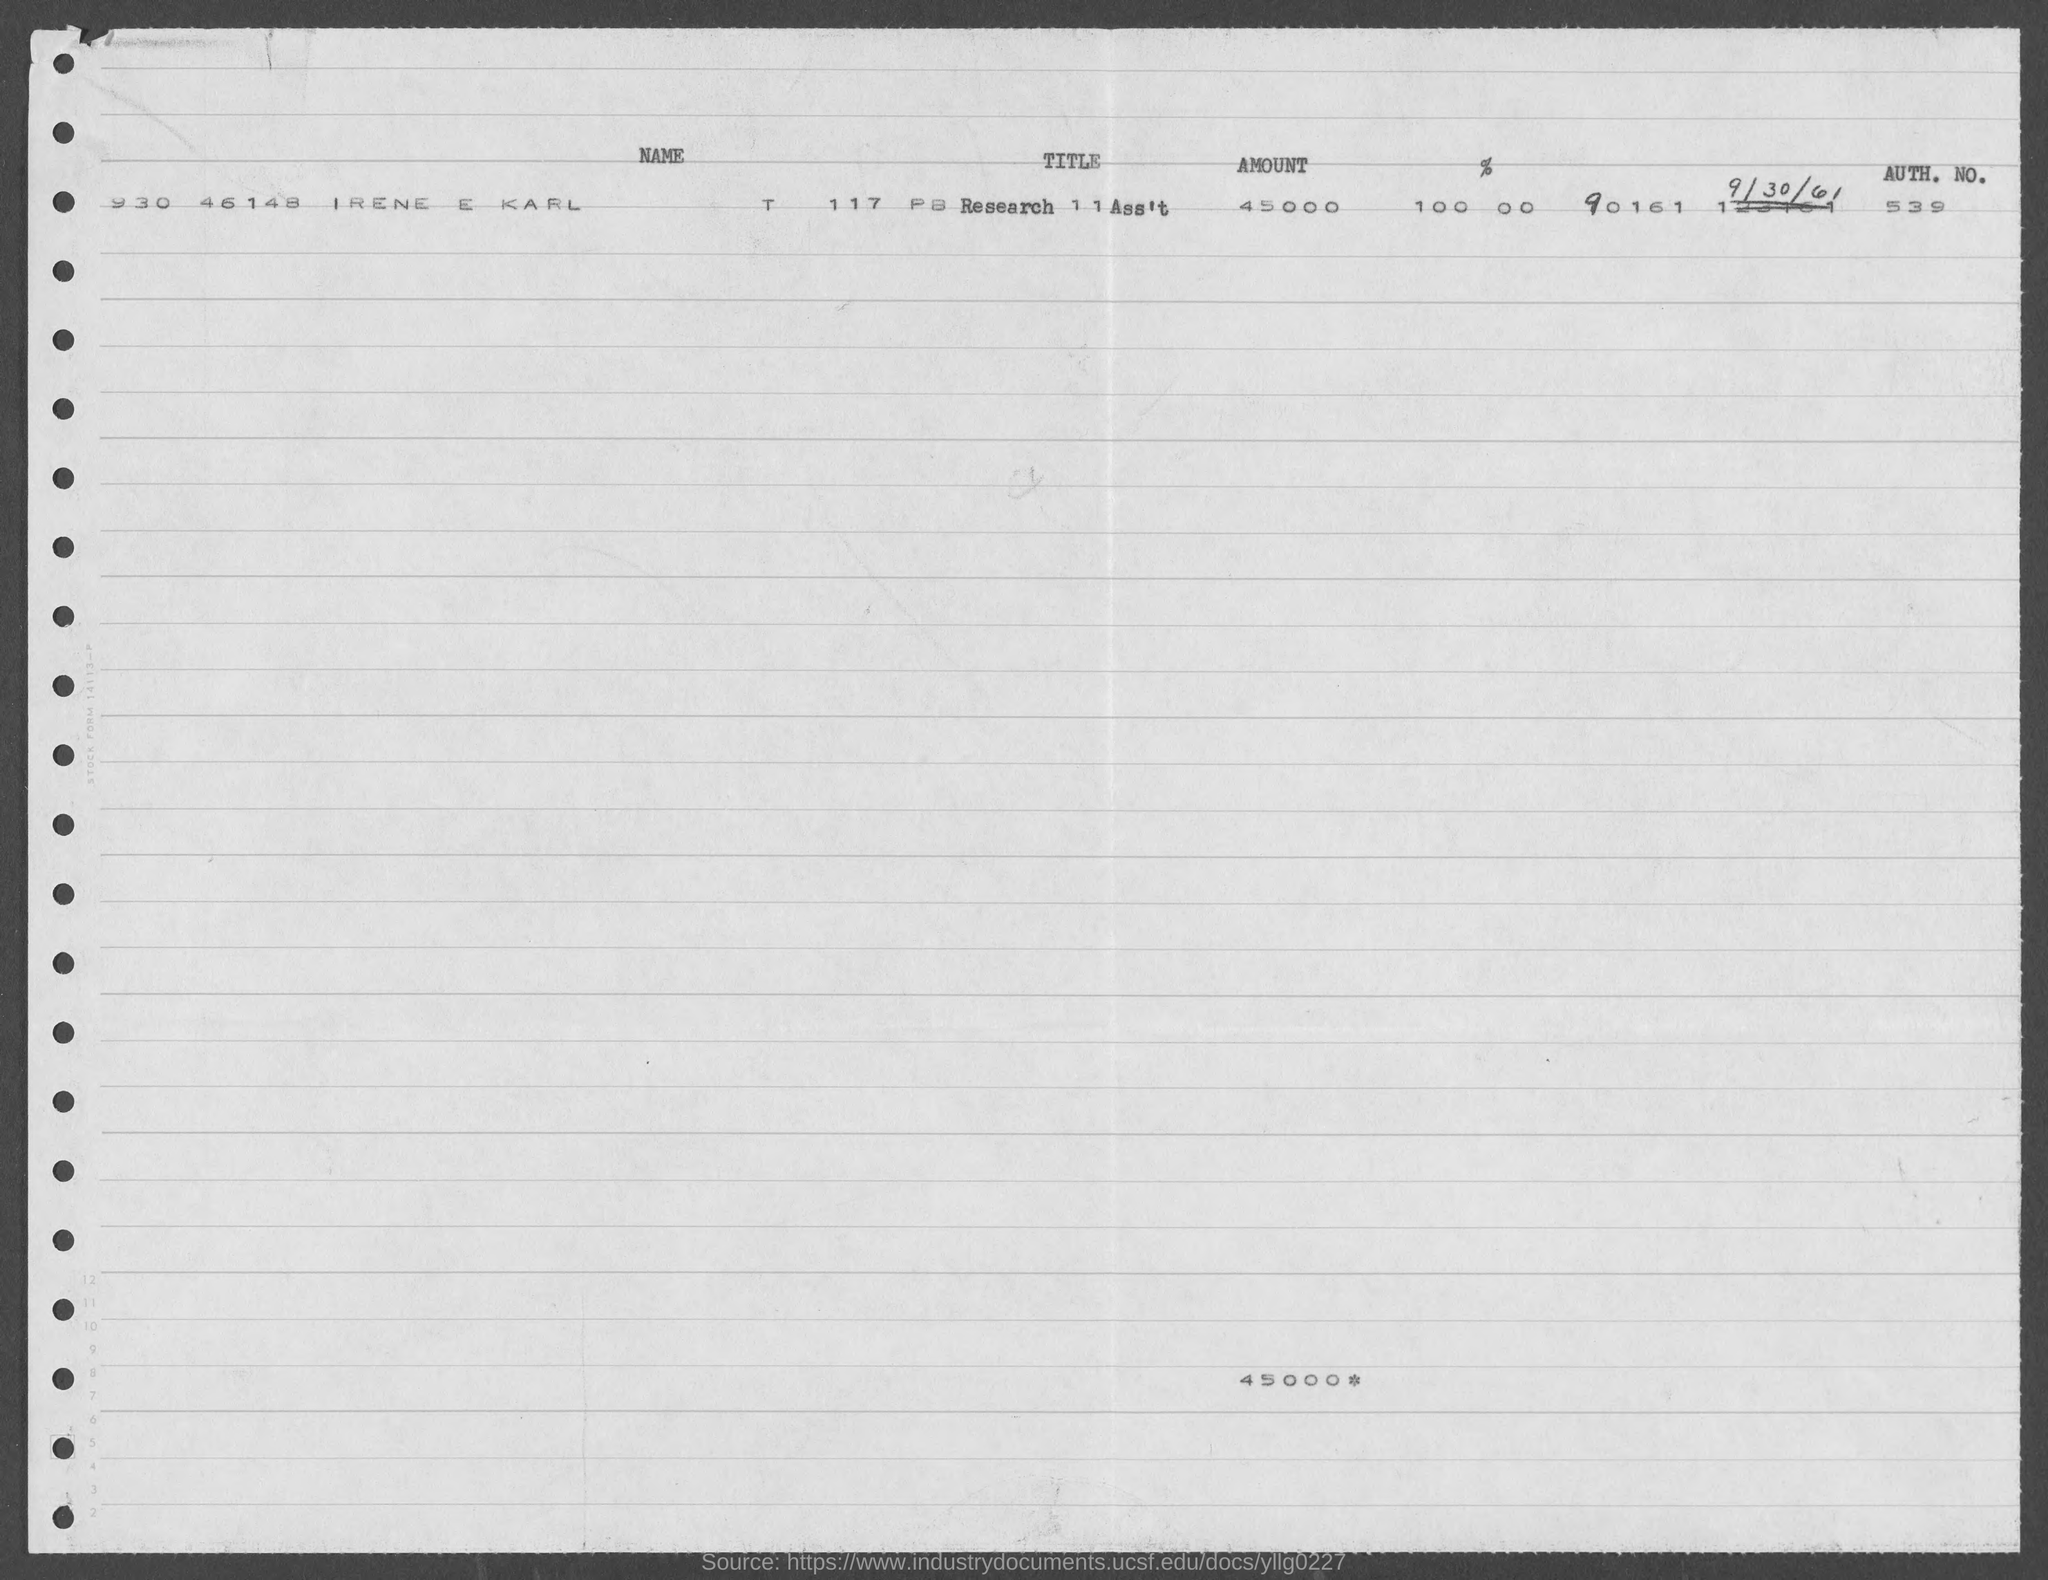Specify some key components in this picture. Could you please provide the authentication number, which is 539 and above? The document states that 45000 is the mentioned amount. 